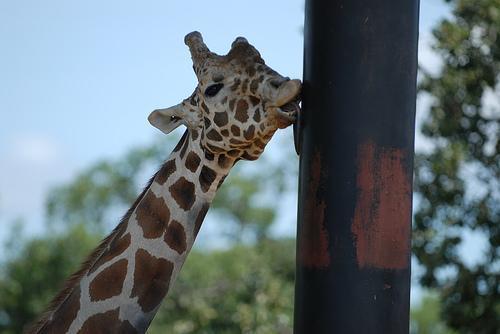How many giraffes are in the picture?
Give a very brief answer. 1. How many of the giraffe's ears are visible?
Give a very brief answer. 1. How many brown spots can you see on the pole?
Give a very brief answer. 2. 